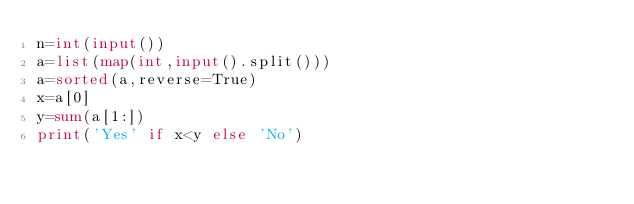Convert code to text. <code><loc_0><loc_0><loc_500><loc_500><_Python_>n=int(input())
a=list(map(int,input().split()))
a=sorted(a,reverse=True)
x=a[0]
y=sum(a[1:])
print('Yes' if x<y else 'No')</code> 